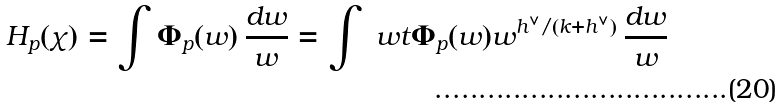Convert formula to latex. <formula><loc_0><loc_0><loc_500><loc_500>H _ { p } ( \chi ) = \int \Phi _ { p } ( w ) \, \frac { d w } { w } = \int \ w t \Phi _ { p } ( w ) w ^ { h ^ { \vee } / ( k + h ^ { \vee } ) } \, \frac { d w } { w }</formula> 